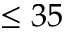<formula> <loc_0><loc_0><loc_500><loc_500>\leq 3 5</formula> 